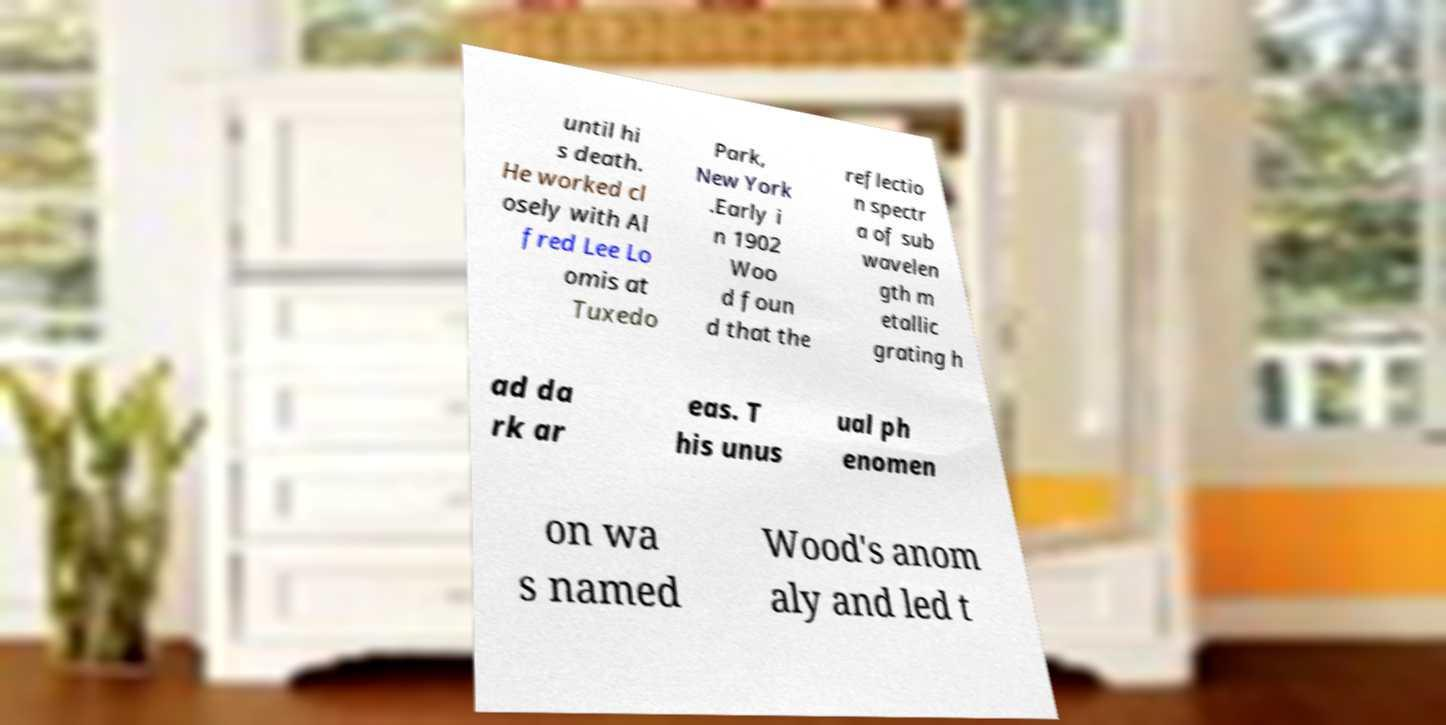Can you read and provide the text displayed in the image?This photo seems to have some interesting text. Can you extract and type it out for me? until hi s death. He worked cl osely with Al fred Lee Lo omis at Tuxedo Park, New York .Early i n 1902 Woo d foun d that the reflectio n spectr a of sub wavelen gth m etallic grating h ad da rk ar eas. T his unus ual ph enomen on wa s named Wood's anom aly and led t 